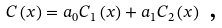<formula> <loc_0><loc_0><loc_500><loc_500>C \left ( x \right ) = a _ { 0 } C _ { 1 } \left ( x \right ) + a _ { 1 } C _ { 2 } \left ( x \right ) \text { ,}</formula> 